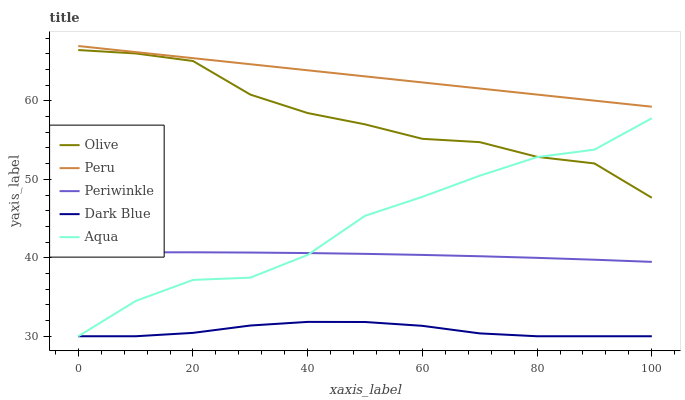Does Dark Blue have the minimum area under the curve?
Answer yes or no. Yes. Does Peru have the maximum area under the curve?
Answer yes or no. Yes. Does Aqua have the minimum area under the curve?
Answer yes or no. No. Does Aqua have the maximum area under the curve?
Answer yes or no. No. Is Peru the smoothest?
Answer yes or no. Yes. Is Aqua the roughest?
Answer yes or no. Yes. Is Dark Blue the smoothest?
Answer yes or no. No. Is Dark Blue the roughest?
Answer yes or no. No. Does Periwinkle have the lowest value?
Answer yes or no. No. Does Peru have the highest value?
Answer yes or no. Yes. Does Aqua have the highest value?
Answer yes or no. No. Is Dark Blue less than Olive?
Answer yes or no. Yes. Is Peru greater than Dark Blue?
Answer yes or no. Yes. Does Dark Blue intersect Olive?
Answer yes or no. No. 